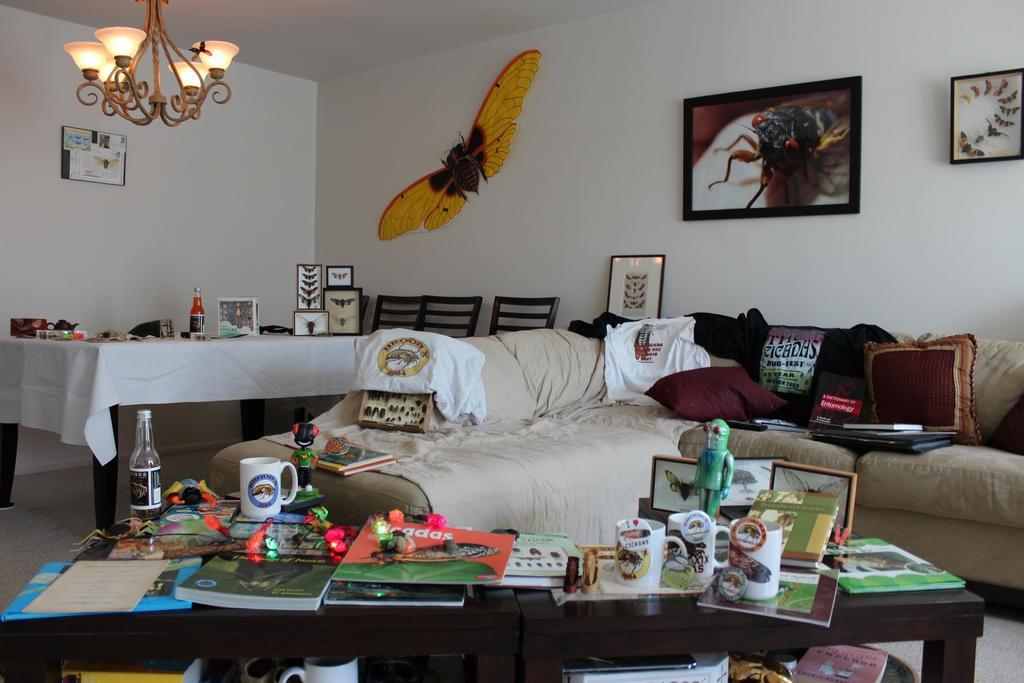Could you give a brief overview of what you see in this image? In the image we can see there is sofa on which there are shirts and cushions kept. On table there are books, mug and toys kept, on the wall there are photo frames and butterfly sticker and there is a dining table on which there is juice bottle and kettle. 